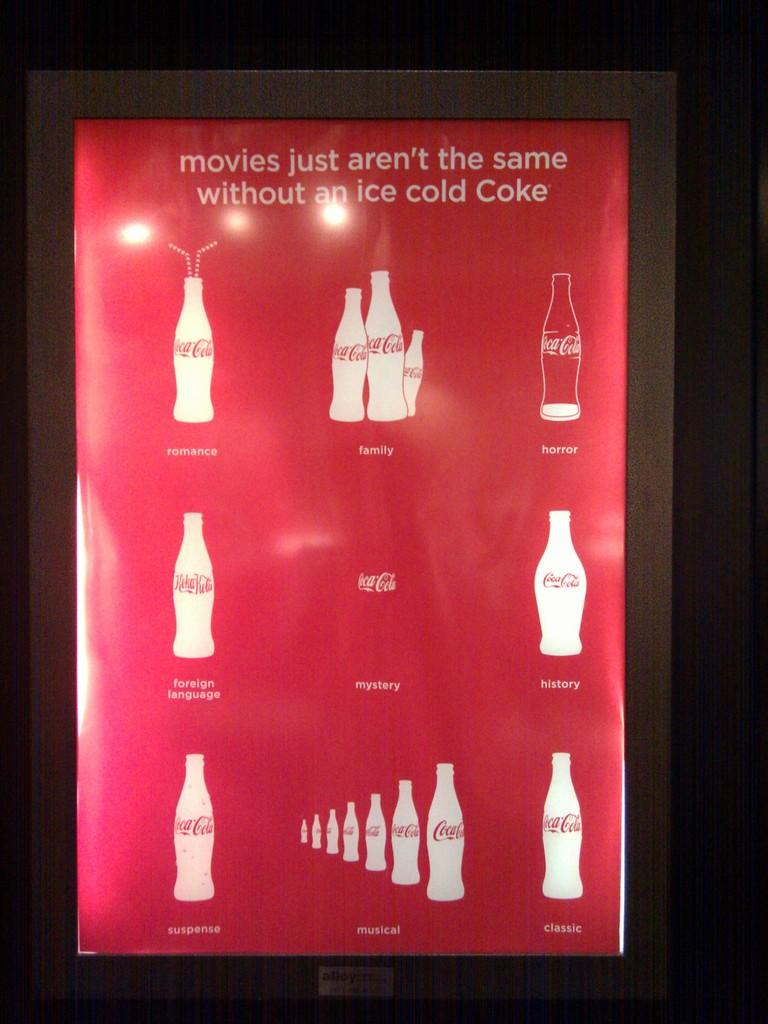<image>
Summarize the visual content of the image. An ad for Coca Cola says movies just arent the same without an ice cold coke 